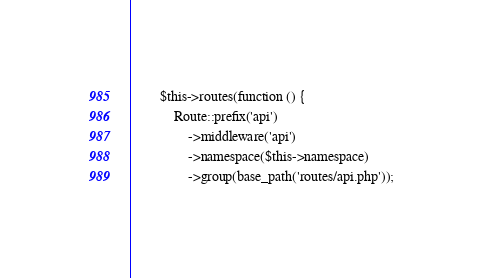<code> <loc_0><loc_0><loc_500><loc_500><_PHP_>        $this->routes(function () {
            Route::prefix('api')
                ->middleware('api')
                ->namespace($this->namespace)
                ->group(base_path('routes/api.php'));
</code> 